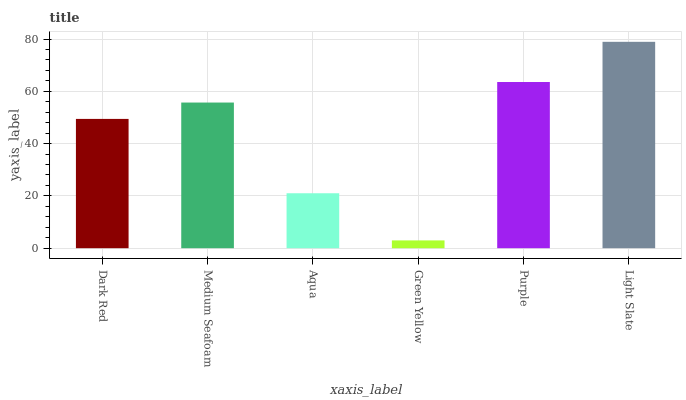Is Green Yellow the minimum?
Answer yes or no. Yes. Is Light Slate the maximum?
Answer yes or no. Yes. Is Medium Seafoam the minimum?
Answer yes or no. No. Is Medium Seafoam the maximum?
Answer yes or no. No. Is Medium Seafoam greater than Dark Red?
Answer yes or no. Yes. Is Dark Red less than Medium Seafoam?
Answer yes or no. Yes. Is Dark Red greater than Medium Seafoam?
Answer yes or no. No. Is Medium Seafoam less than Dark Red?
Answer yes or no. No. Is Medium Seafoam the high median?
Answer yes or no. Yes. Is Dark Red the low median?
Answer yes or no. Yes. Is Dark Red the high median?
Answer yes or no. No. Is Light Slate the low median?
Answer yes or no. No. 